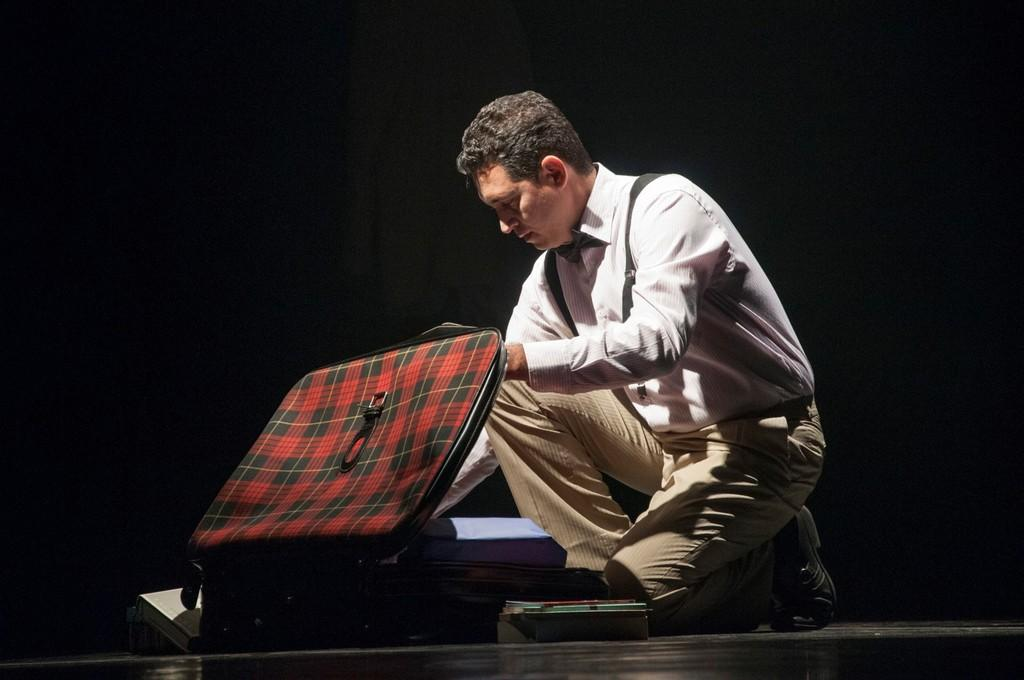What is the man in the image doing? The man is sitting in the image. How is the man sitting? The man is sitting on his knee. What is the man wearing? The man is wearing clothes and shoes. What object is present in the image that might be used for traveling? There is a suitcase in the image. What is inside the suitcase? The suitcase contains books. What type of surface is visible beneath the man? There is a floor visible in the image. What color is the background of the image? The background of the image is black. Can you see any ducks or a stove on the poster? There are no ducks or stove present on the poster; it features a man sitting with a suitcase. Is there an iron visible in the image? There is no iron visible in the image. 